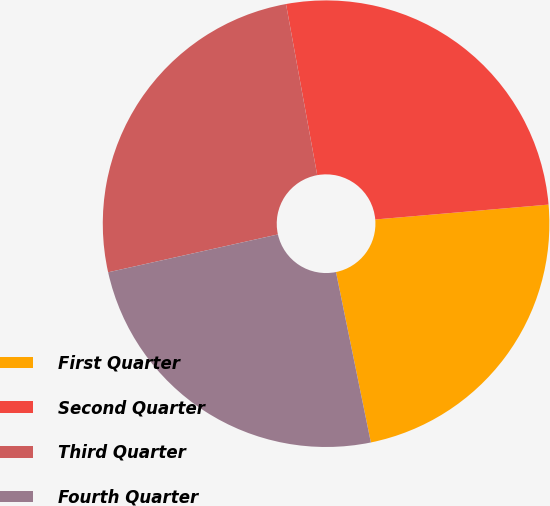<chart> <loc_0><loc_0><loc_500><loc_500><pie_chart><fcel>First Quarter<fcel>Second Quarter<fcel>Third Quarter<fcel>Fourth Quarter<nl><fcel>23.15%<fcel>26.51%<fcel>25.62%<fcel>24.72%<nl></chart> 